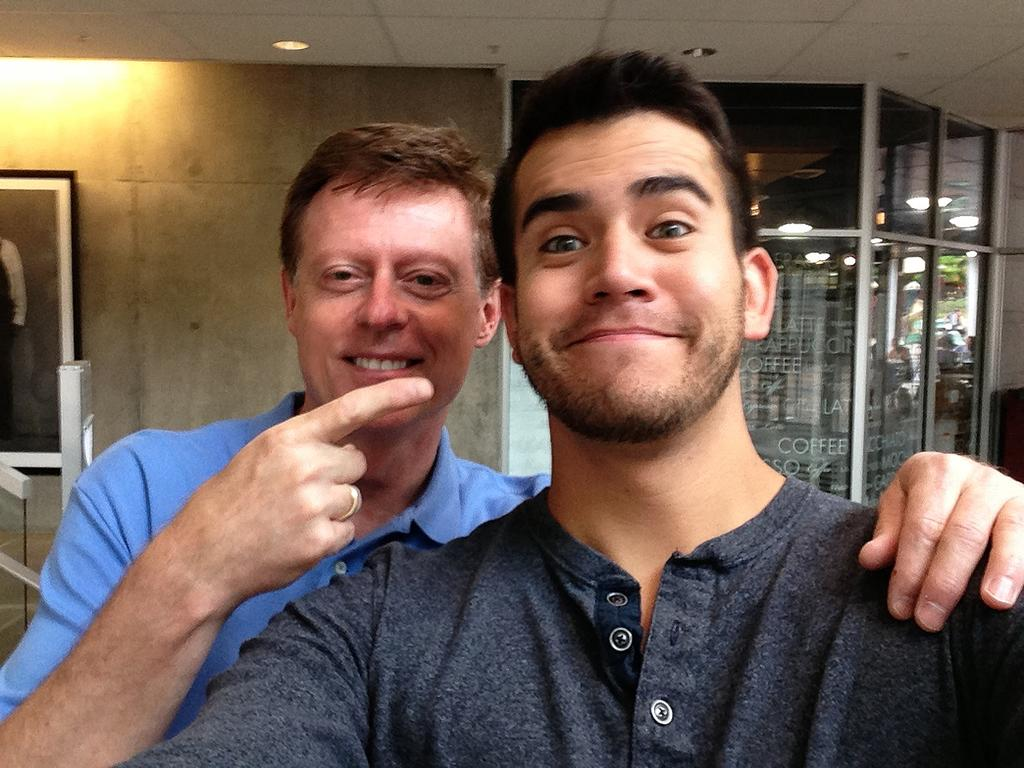What are the men in the image doing? The men in the image are standing and smiling. What can be seen in the background of the image? There is a wall hanging, electric lights, and a store in the background of the image. Where is the faucet located in the image? There is no faucet present in the image. What type of soap is being used by the men in the image? There is no soap or indication of any cleaning activity in the image. 